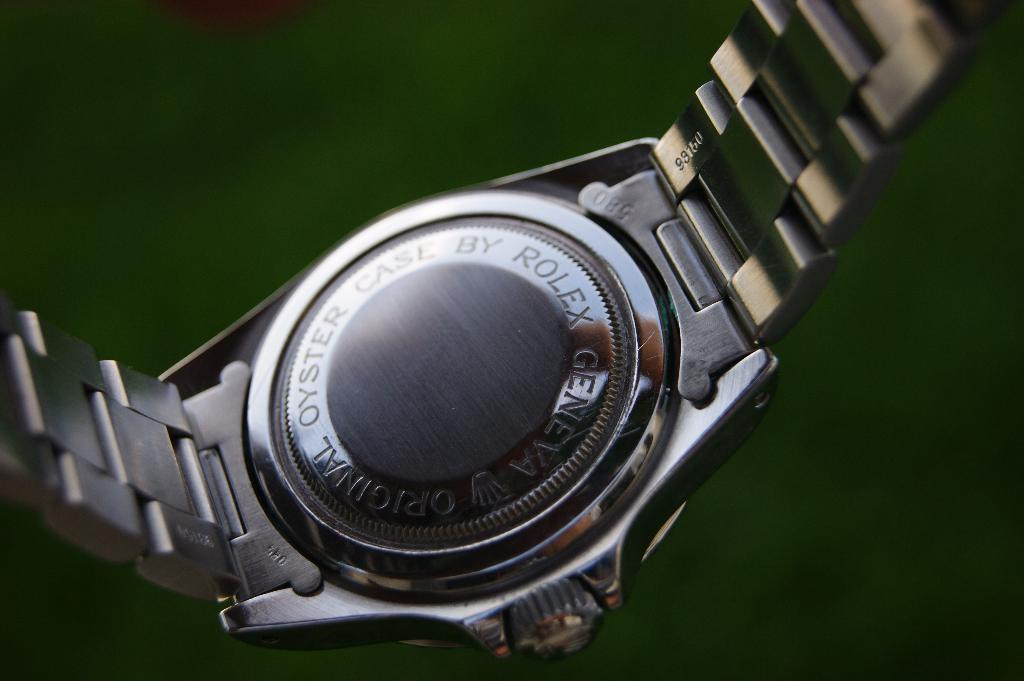<image>
Share a concise interpretation of the image provided. A Rolex watch from Geneva is hanging over a green surface. 